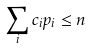<formula> <loc_0><loc_0><loc_500><loc_500>\sum _ { i } c _ { i } p _ { i } \leq n</formula> 